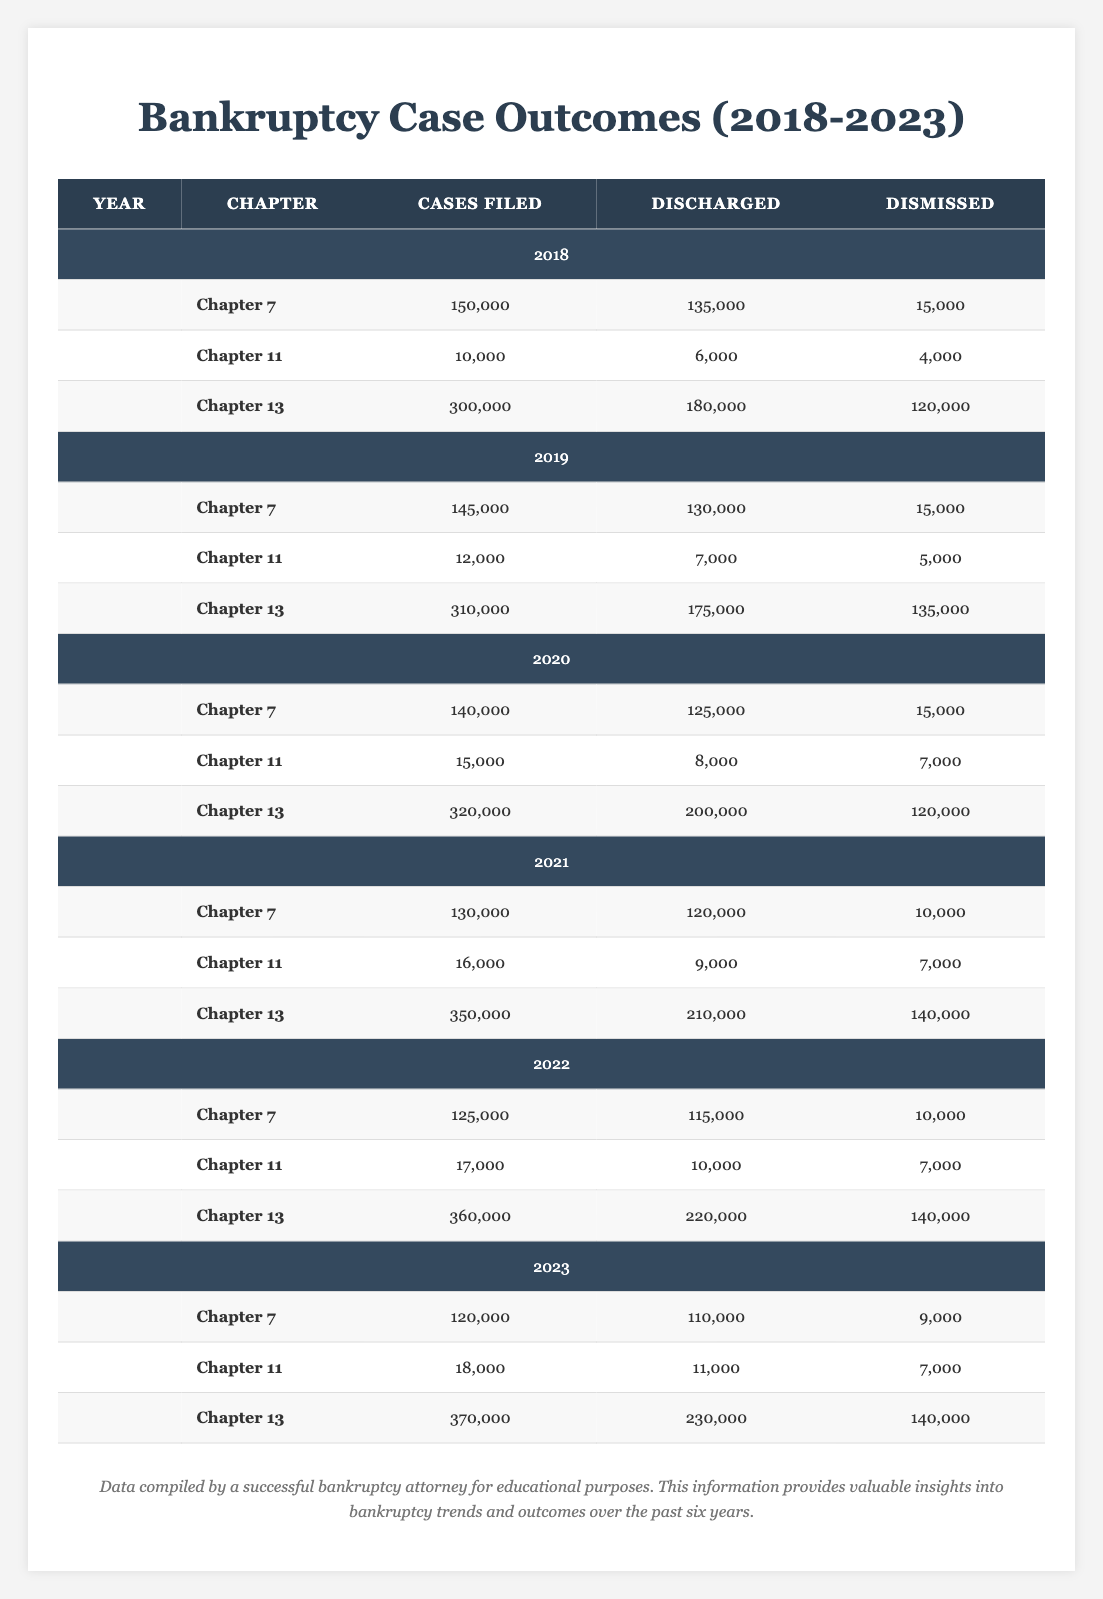What is the total number of Chapter 7 cases filed in 2020? In 2020, the table shows that 140,000 Chapter 7 cases were filed.
Answer: 140000 How many Chapter 13 cases were discharged in 2021? The table lists 210,000 discharges for Chapter 13 in 2021.
Answer: 210000 Which year had the highest number of Chapter 11 cases dismissed? In 2019, Chapter 11 had 5,000 cases dismissed, which is the highest among the listed years.
Answer: 5000 What is the difference in the number of Chapter 7 cases filed between 2018 and 2023? The number of Chapter 7 cases filed in 2018 was 150,000 and in 2023 it was 120,000. The difference is 150,000 - 120,000 = 30,000.
Answer: 30000 How many total Chapter 13 cases were filed from 2018 to 2023? Adding up the Chapter 13 cases filed each year: 300,000 (2018) + 310,000 (2019) + 320,000 (2020) + 350,000 (2021) + 360,000 (2022) + 370,000 (2023) totals 2,010,000.
Answer: 2010000 In which year was the discharge rate for Chapter 11 the highest? Calculating the discharge rate for each year by dividing discharged by cases filed: 2018 (60%) < 2019 (58.33%) < 2020 (53.33%) < 2021 (56.25%) < 2022 (58.82%) < 2023 (61.11%). The highest discharge rate is in 2023.
Answer: 2023 Was there an increase in Chapter 7 cases filed from 2021 to 2022? In 2021, 130,000 Chapter 7 cases were filed, and in 2022 there were 125,000. This shows a decrease, not an increase.
Answer: No What is the total number of cases (discharged plus dismissed) for Chapter 13 in 2020? For Chapter 13 in 2020, the discharged cases were 200,000 and dismissed cases were 120,000. Adding these gives 200,000 + 120,000 = 320,000.
Answer: 320000 What year's Chapter 7 cases had the lowest discharge number? The lowest discharge number for Chapter 7 was in 2023 with 110,000 discharged cases.
Answer: 2023 What is the average number of Chapter 11 cases dismissed from 2018 to 2023? The dismissed cases for Chapter 11 over these years are: 4,000 (2018), 5,000 (2019), 7,000 (2020), 7,000 (2021), 7,000 (2022), 7,000 (2023). The total is 4,000 + 5,000 + 7,000 + 7,000 + 7,000 + 7,000 = 37,000. Dividing by 6 gives an average of approximately 6,166.67.
Answer: 6166.67 